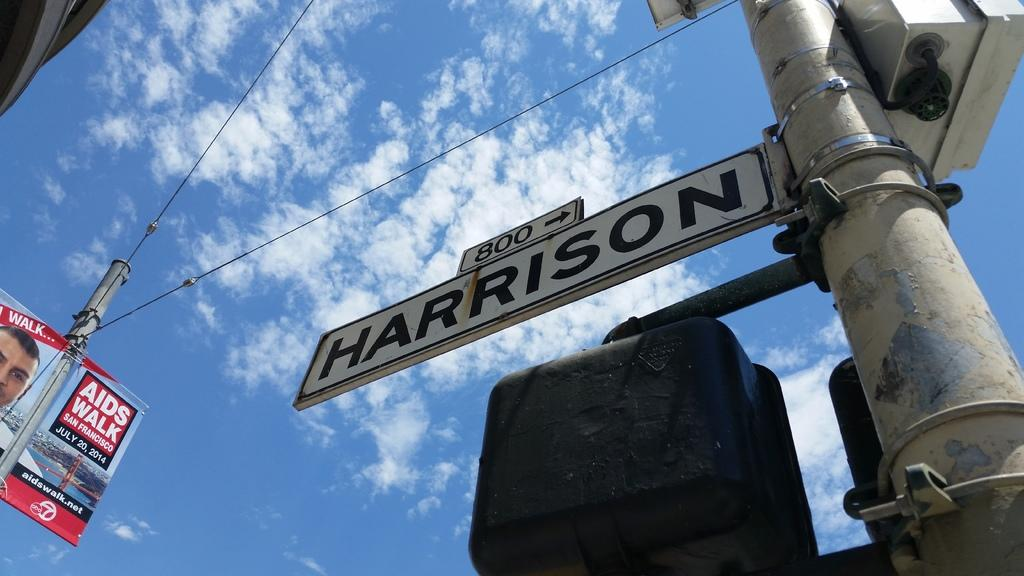<image>
Give a short and clear explanation of the subsequent image. The AIDS walk will be held in San Francisco 